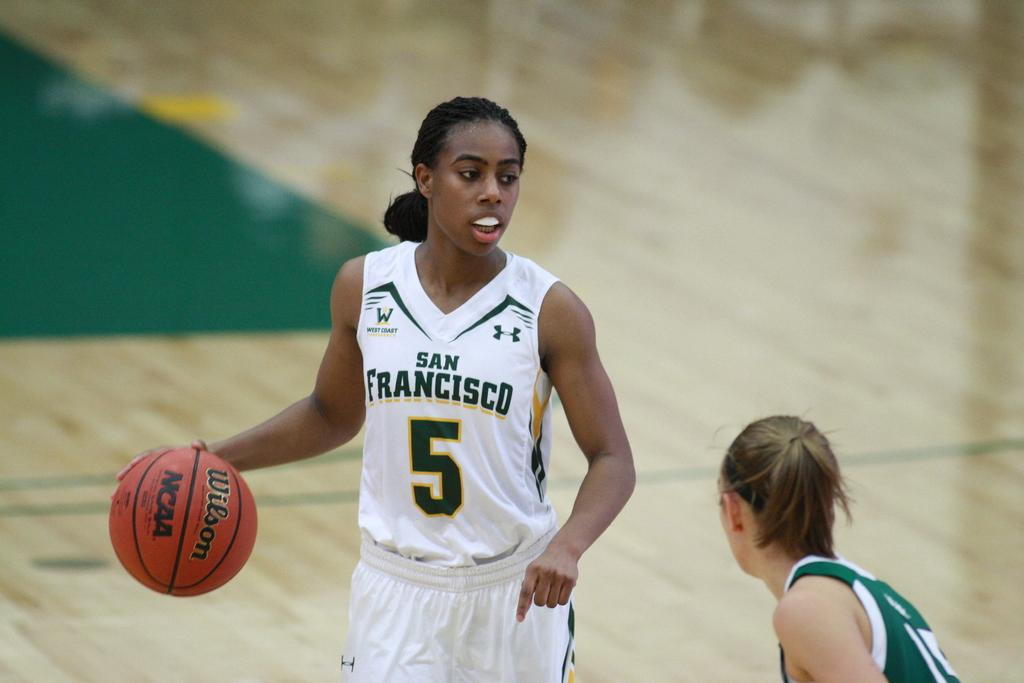<image>
Offer a succinct explanation of the picture presented. A female basketball player in white whose top says San Francisco and the number 5 looks for where to pass the ball next. 